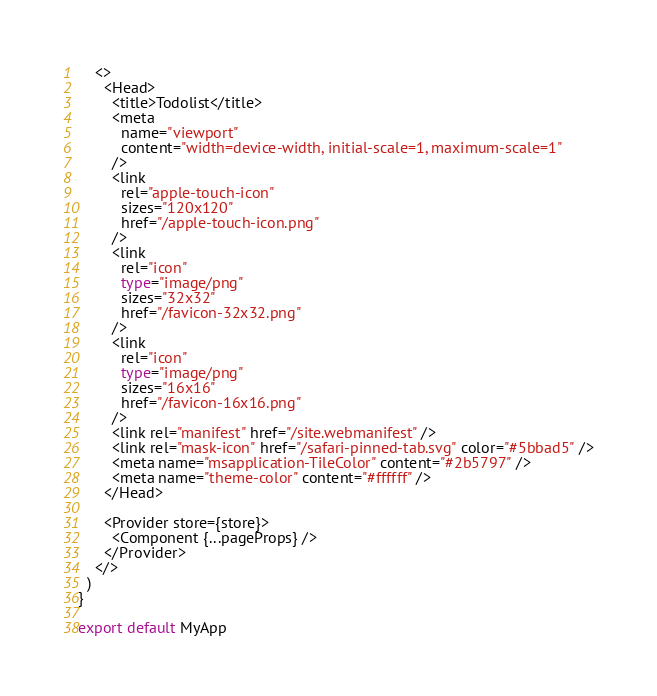Convert code to text. <code><loc_0><loc_0><loc_500><loc_500><_TypeScript_>    <>
      <Head>
        <title>Todolist</title>
        <meta
          name="viewport"
          content="width=device-width, initial-scale=1, maximum-scale=1"
        />
        <link
          rel="apple-touch-icon"
          sizes="120x120"
          href="/apple-touch-icon.png"
        />
        <link
          rel="icon"
          type="image/png"
          sizes="32x32"
          href="/favicon-32x32.png"
        />
        <link
          rel="icon"
          type="image/png"
          sizes="16x16"
          href="/favicon-16x16.png"
        />
        <link rel="manifest" href="/site.webmanifest" />
        <link rel="mask-icon" href="/safari-pinned-tab.svg" color="#5bbad5" />
        <meta name="msapplication-TileColor" content="#2b5797" />
        <meta name="theme-color" content="#ffffff" />
      </Head>

      <Provider store={store}>
        <Component {...pageProps} />
      </Provider>
    </>
  )
}

export default MyApp
</code> 